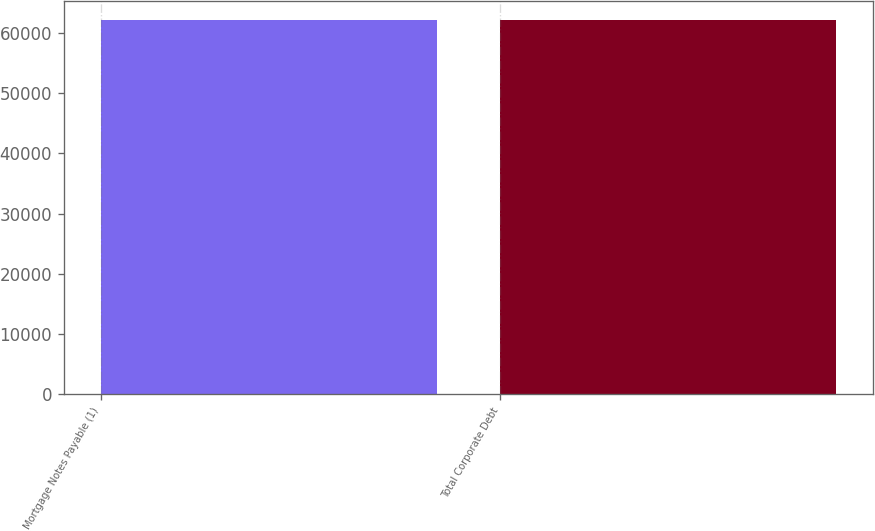Convert chart to OTSL. <chart><loc_0><loc_0><loc_500><loc_500><bar_chart><fcel>Mortgage Notes Payable (1)<fcel>Total Corporate Debt<nl><fcel>62224<fcel>62224.1<nl></chart> 